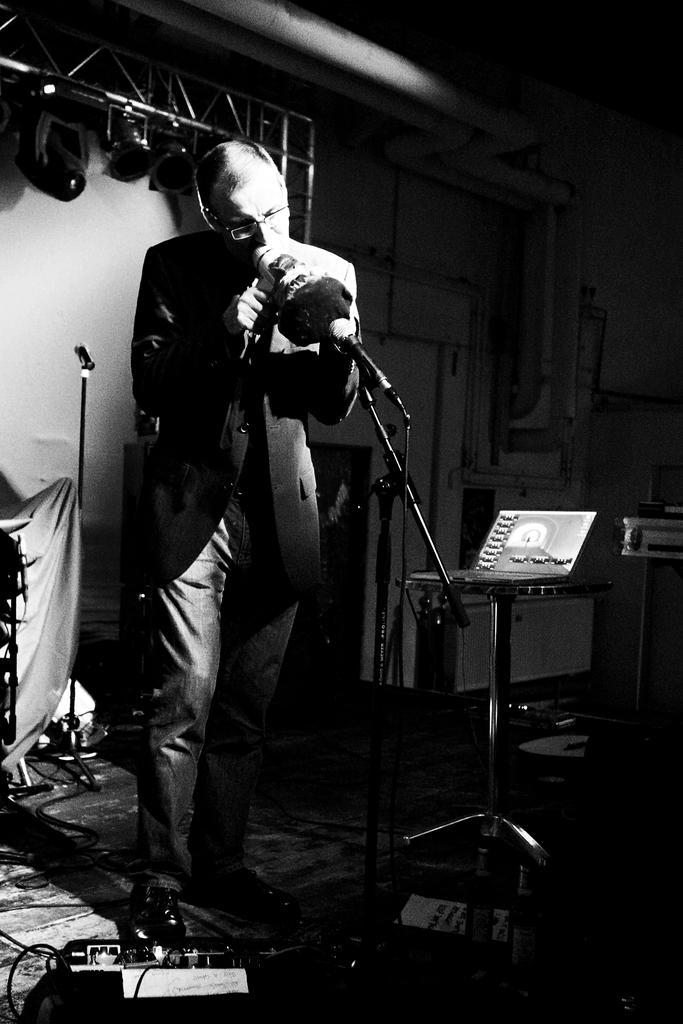How would you summarize this image in a sentence or two? In this picture I can see there is a man standing and he is having spectacles and there are few equipment placed, there is an iron frame in the backdrop with few lights. There is a laptop at right side and there is an iron frame in the backdrop with few lights. 